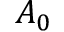<formula> <loc_0><loc_0><loc_500><loc_500>A _ { 0 }</formula> 